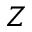<formula> <loc_0><loc_0><loc_500><loc_500>Z</formula> 